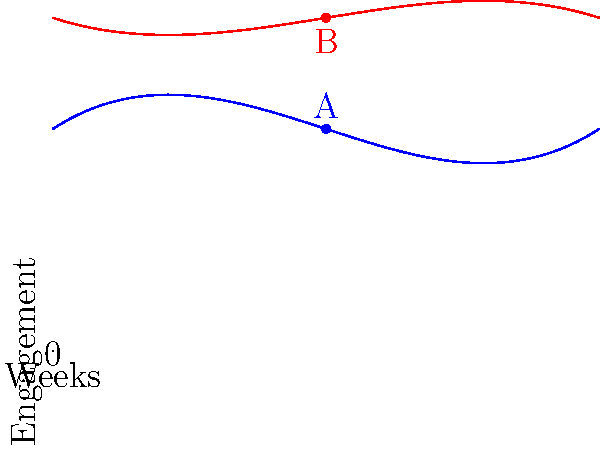The graph shows the engagement trends of two marketing campaigns over a 4-week period, represented by polynomial functions. Campaign A is represented by the blue curve $f(x) = 0.5x^3 - 3x^2 + 4x + 10$, and Campaign B by the red curve $g(x) = -0.25x^3 + 1.5x^2 - 2x + 15$, where $x$ represents the number of weeks. At week 2, which campaign has higher engagement, and by how much? To solve this problem, we need to follow these steps:

1. Identify the functions for each campaign:
   Campaign A: $f(x) = 0.5x^3 - 3x^2 + 4x + 10$
   Campaign B: $g(x) = -0.25x^3 + 1.5x^2 - 2x + 15$

2. Calculate the engagement for each campaign at week 2 (x = 2):

   For Campaign A:
   $f(2) = 0.5(2^3) - 3(2^2) + 4(2) + 10$
   $= 0.5(8) - 3(4) + 8 + 10$
   $= 4 - 12 + 8 + 10$
   $= 10$

   For Campaign B:
   $g(2) = -0.25(2^3) + 1.5(2^2) - 2(2) + 15$
   $= -0.25(8) + 1.5(4) - 4 + 15$
   $= -2 + 6 - 4 + 15$
   $= 15$

3. Compare the engagement values:
   Campaign A: 10
   Campaign B: 15

4. Calculate the difference:
   $15 - 10 = 5$

Therefore, at week 2, Campaign B has higher engagement than Campaign A by 5 units.
Answer: Campaign B, by 5 units 